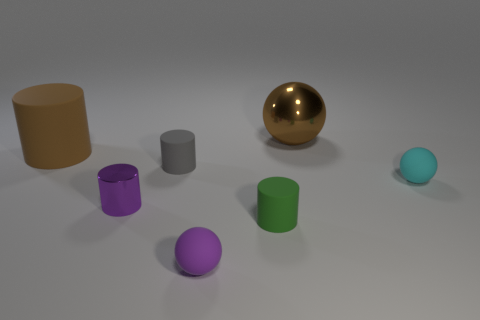Subtract all brown cylinders. How many cylinders are left? 3 Subtract 1 cylinders. How many cylinders are left? 3 Subtract all brown cylinders. How many cylinders are left? 3 Add 1 cyan metal blocks. How many objects exist? 8 Subtract all spheres. How many objects are left? 4 Subtract all red cylinders. Subtract all purple blocks. How many cylinders are left? 4 Subtract all gray rubber things. Subtract all purple cylinders. How many objects are left? 5 Add 4 purple rubber spheres. How many purple rubber spheres are left? 5 Add 2 small yellow shiny cubes. How many small yellow shiny cubes exist? 2 Subtract 0 cyan cylinders. How many objects are left? 7 